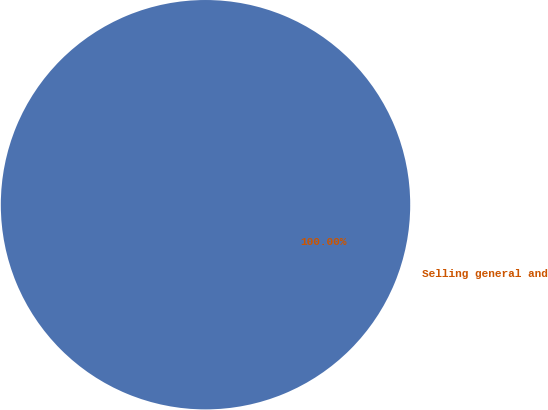Convert chart. <chart><loc_0><loc_0><loc_500><loc_500><pie_chart><fcel>Selling general and<nl><fcel>100.0%<nl></chart> 